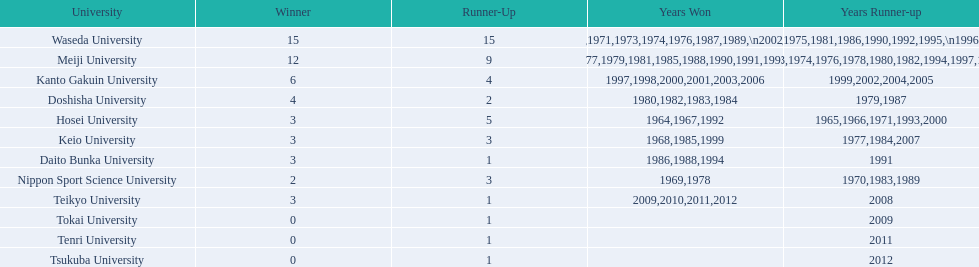Which university had 6 wins? Kanto Gakuin University. Which university had 12 wins? Meiji University. Which university had more than 12 wins? Waseda University. 